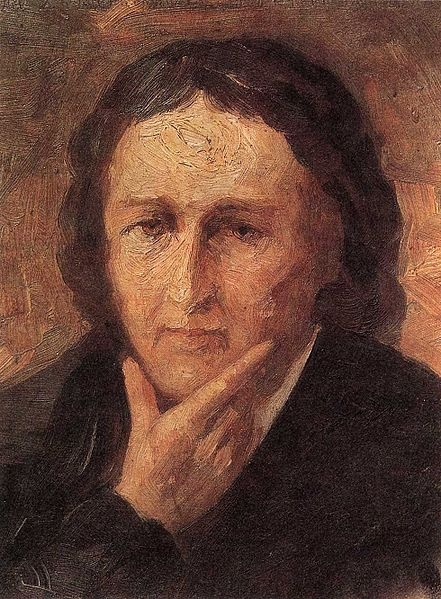What is this photo about? The image is a striking portrait of an individual with long, dark hair. The person's expression is pensive, with their chin resting thoughtfully on their hand. The background features a vibrant blend of warm colors, created with broad and expressive brushstrokes, enhancing the emotional depth and impressionistic ambiance of the artwork. The style is indicative of post-impressionism, characterized by its emphasis on the artist's personal response and emotional expression over realistic representation. This portrait offers not only a detailed depiction of the individual's appearance but also a poignant glimpse into their emotional state or inner world. 